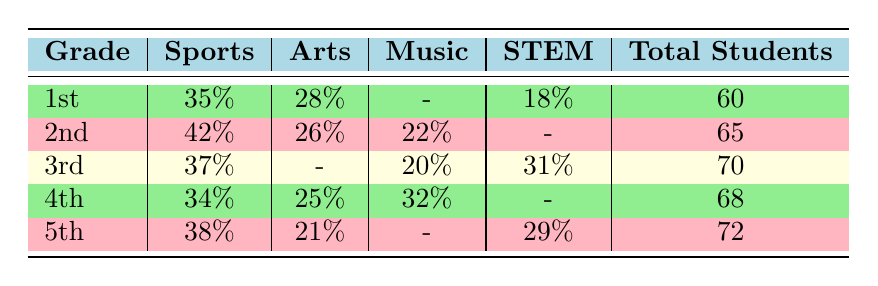What is the participation rate for 1st grade students in Sports? From the table, the 1st grade participation rate in Sports is listed under the Sports column which shows 35%.
Answer: 35% What is the total number of students participating in the 2nd grade Arts activities? The total number of students for 2nd grade is 65, and the participation rate for Arts is noted in that row, but the total students remain the same.
Answer: 65 Which activity had the highest participation rate in the 4th grade? In the 4th grade, the participation rates are 34% in Sports, 25% in Arts, 32% in Music, and no entry for STEM, making the highest rate in Sports at 34%.
Answer: 34% Is there a Music activity for the 1st grade? Looking across the 1st grade row in the Music column, it shows a dash indicating there was no participation recorded for Music.
Answer: No Calculate the average participation rate for Sports across all grades. The Sports participation rates are 35% (1st) + 42% (2nd) + 37% (3rd) + 34% (4th) + 38% (5th). The sum is 186% and there are 5 grades, so the average participation rate is 186% / 5 = 37.2%.
Answer: 37.2% What percentage of 5th grade students participated in Arts? The participation rate for 5th grade in Arts is noted in the table, which shows 21%.
Answer: 21% Is participation in STEM higher in 3rd grade or 5th grade? The participation rate for 3rd grade in STEM is 31% while for 5th grade it is 29%. Since 31% is greater than 29%, participation is higher in 3rd grade.
Answer: 3rd grade Among all grades, which activity type has the least participation rate? Reviewing the participation rates of all activity types, the lowest recorded rates are 18% in STEM for 1st grade, which is less than all others in this table.
Answer: 18% What is the total participation rate for Arts across grades 2 to 4? The Arts participation rates are 26% (2nd) + 25% (4th) = 51%. There is no Arts entry for 3rd grade. Thus, the total participation rate for Arts across grades 2 to 4 is 51%.
Answer: 51% 